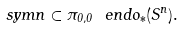Convert formula to latex. <formula><loc_0><loc_0><loc_500><loc_500>\ s y m { n } \subset \pi _ { 0 , 0 } \ e n d o _ { * } ( S ^ { n } ) .</formula> 